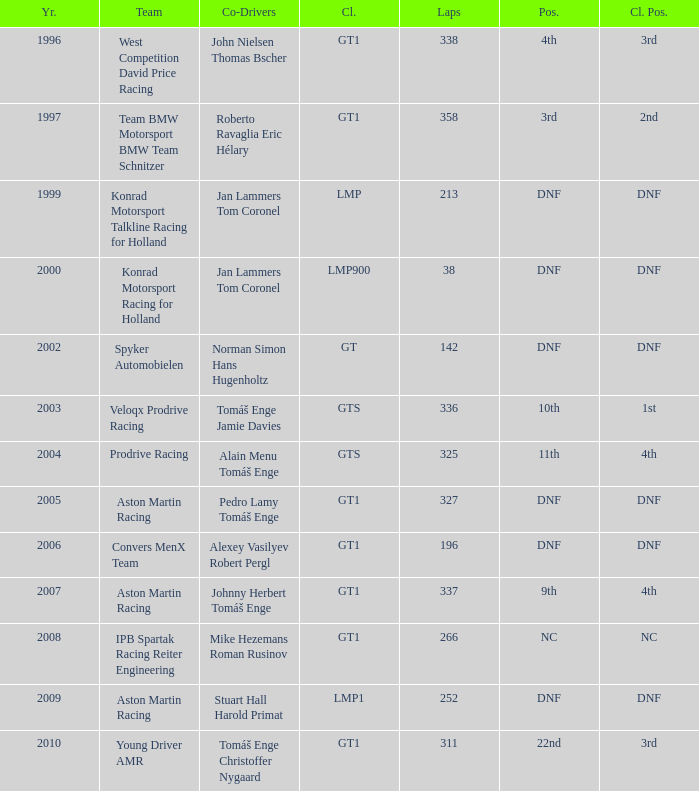What was the position in 1997? 3rd. 